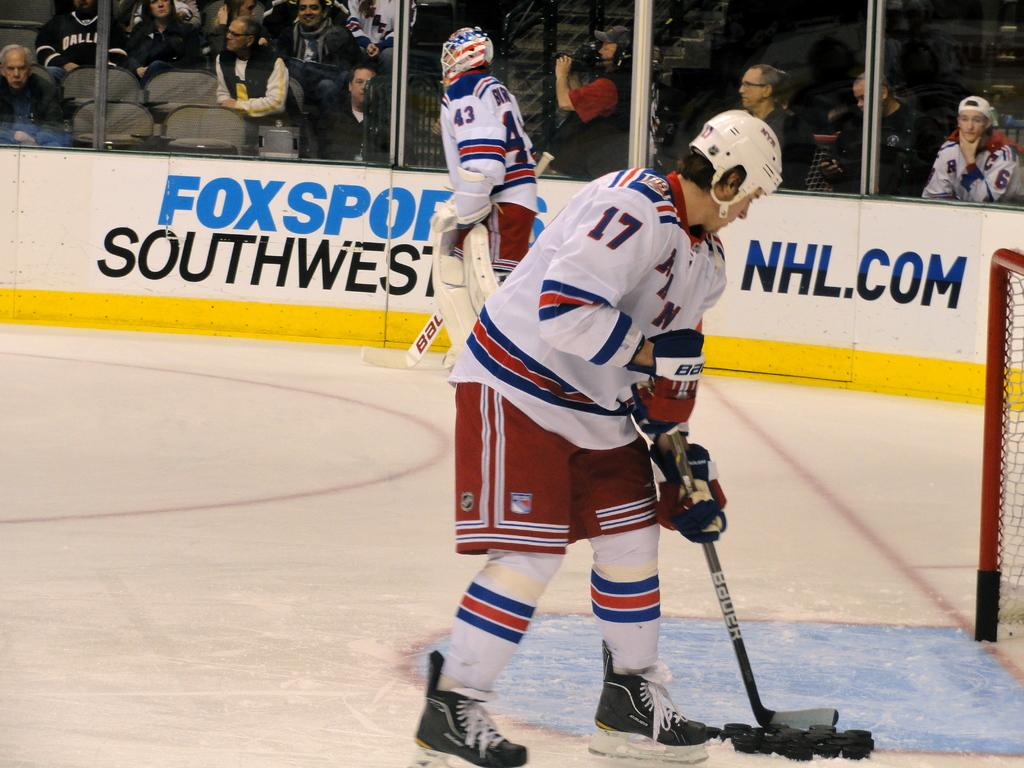<image>
Share a concise interpretation of the image provided. The New York Rangers are playing hockey near a Southwest airlines advertisement. 